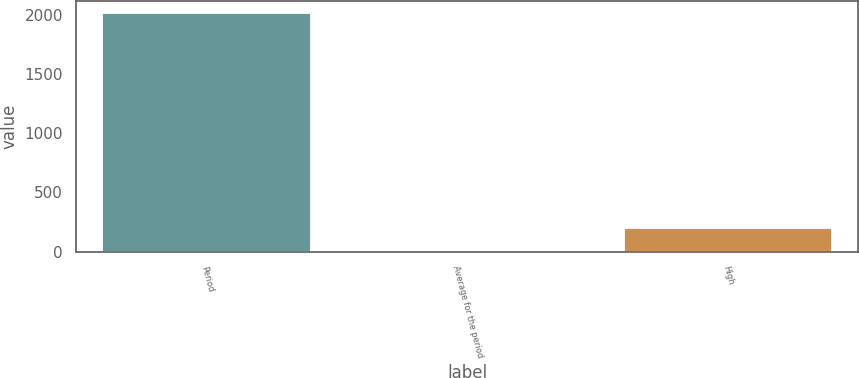<chart> <loc_0><loc_0><loc_500><loc_500><bar_chart><fcel>Period<fcel>Average for the period<fcel>High<nl><fcel>2013<fcel>1<fcel>202.2<nl></chart> 